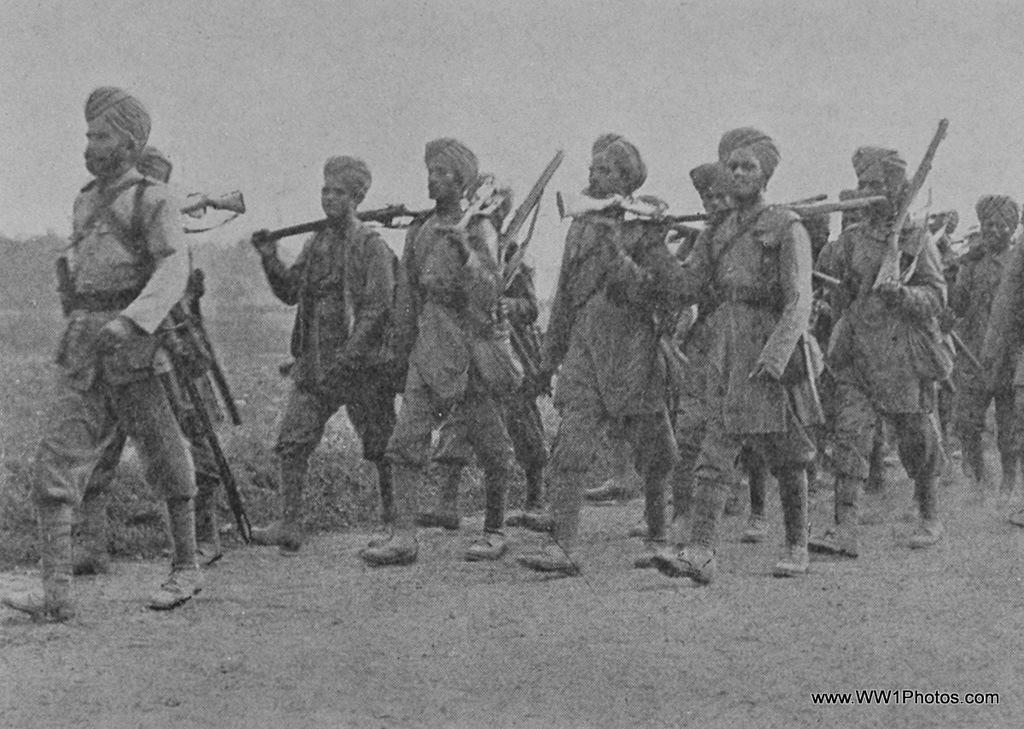Who is present in the image? There are men in the image. Where are the men located in the image? The men are in the center of the image. What are the men holding in their hands? The men are holding guns in their hands. How many bikes are visible in the image? There are no bikes present in the image. What type of rainstorm can be seen in the image? There is no rainstorm present in the image. 